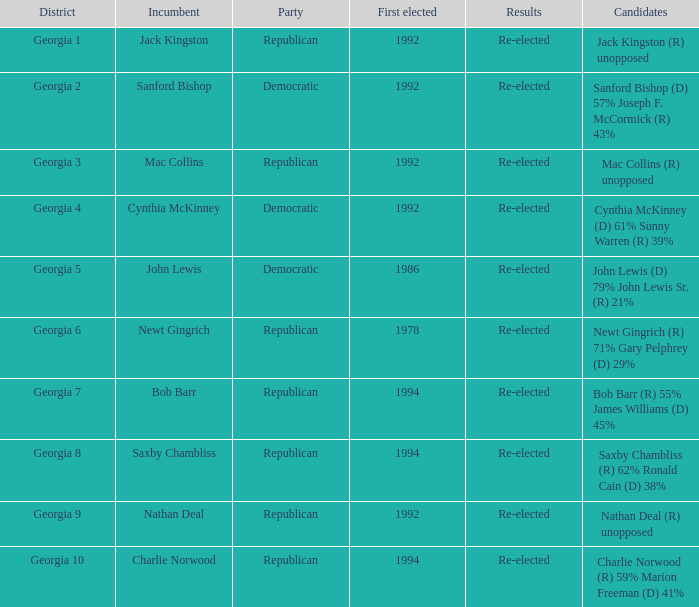Which individuals ran for office in the election where saxby chambliss held the incumbent position? Saxby Chambliss (R) 62% Ronald Cain (D) 38%. 